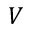Convert formula to latex. <formula><loc_0><loc_0><loc_500><loc_500>V</formula> 